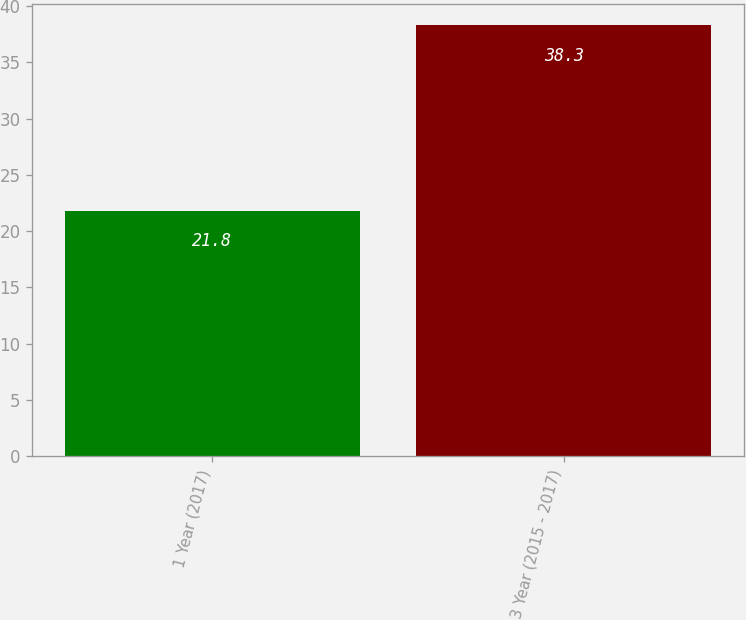<chart> <loc_0><loc_0><loc_500><loc_500><bar_chart><fcel>1 Year (2017)<fcel>3 Year (2015 - 2017)<nl><fcel>21.8<fcel>38.3<nl></chart> 